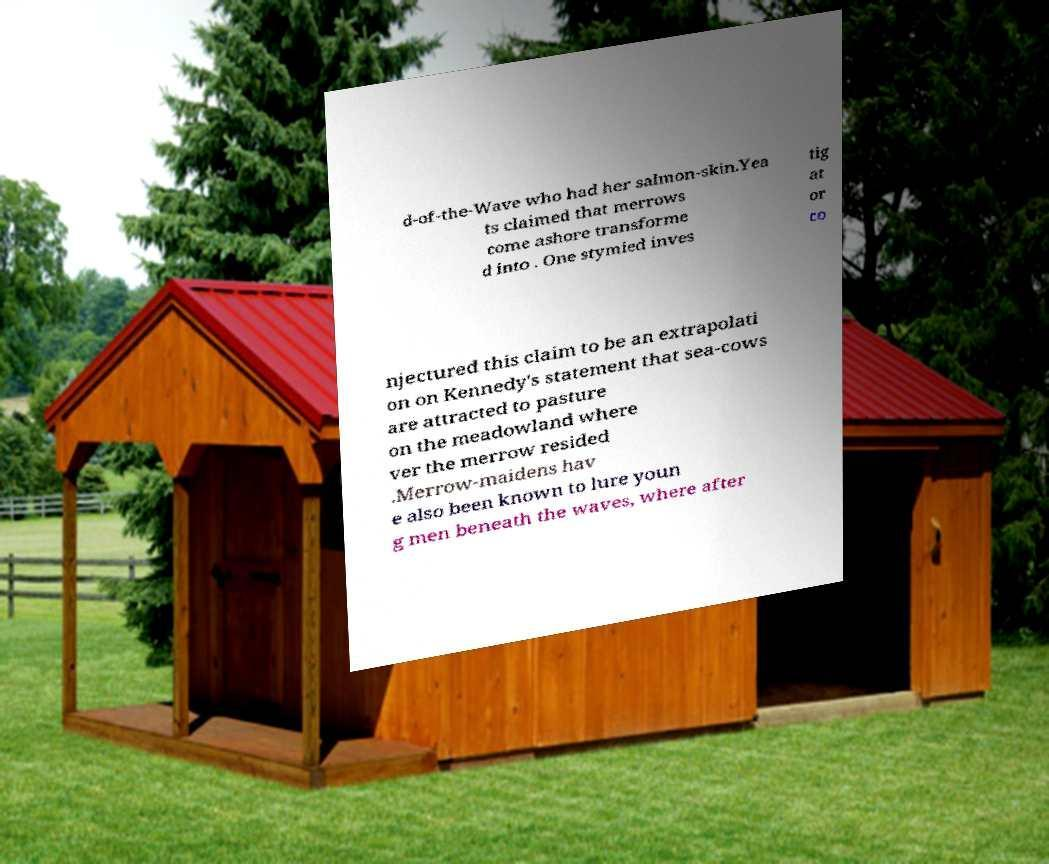Could you extract and type out the text from this image? d-of-the-Wave who had her salmon-skin.Yea ts claimed that merrows come ashore transforme d into . One stymied inves tig at or co njectured this claim to be an extrapolati on on Kennedy's statement that sea-cows are attracted to pasture on the meadowland where ver the merrow resided .Merrow-maidens hav e also been known to lure youn g men beneath the waves, where after 